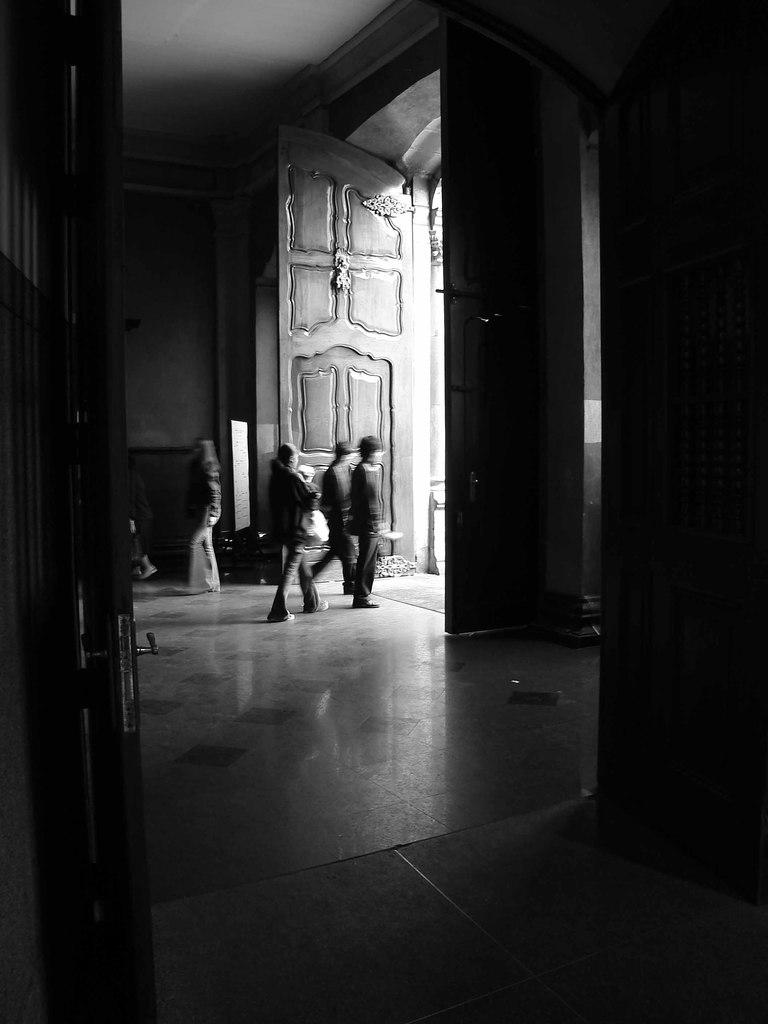How many people are in the image? There is a group of people in the image. Where are the people located? The people are standing inside a building. What can be seen on the walls in the image? There is a wall visible in the image. How can people enter or exit the building? There are doors to the building in the image. What is the color scheme of the image? The image is black and white. What is the price of the shock absorber for the beginner's bicycle in the image? There is no bicycle, shock absorber, or price information present in the image. 